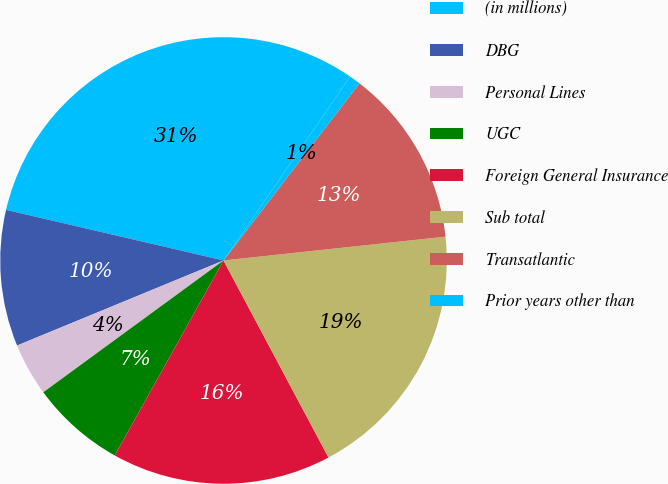<chart> <loc_0><loc_0><loc_500><loc_500><pie_chart><fcel>(in millions)<fcel>DBG<fcel>Personal Lines<fcel>UGC<fcel>Foreign General Insurance<fcel>Sub total<fcel>Transatlantic<fcel>Prior years other than<nl><fcel>30.96%<fcel>9.86%<fcel>3.83%<fcel>6.85%<fcel>15.89%<fcel>18.91%<fcel>12.88%<fcel>0.82%<nl></chart> 